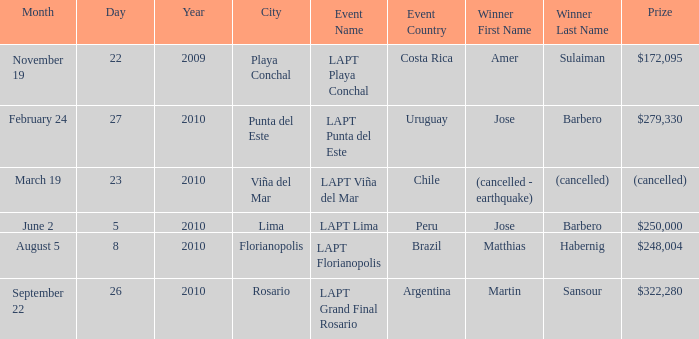Who is the winner in the city of lima? Jose Barbero. 